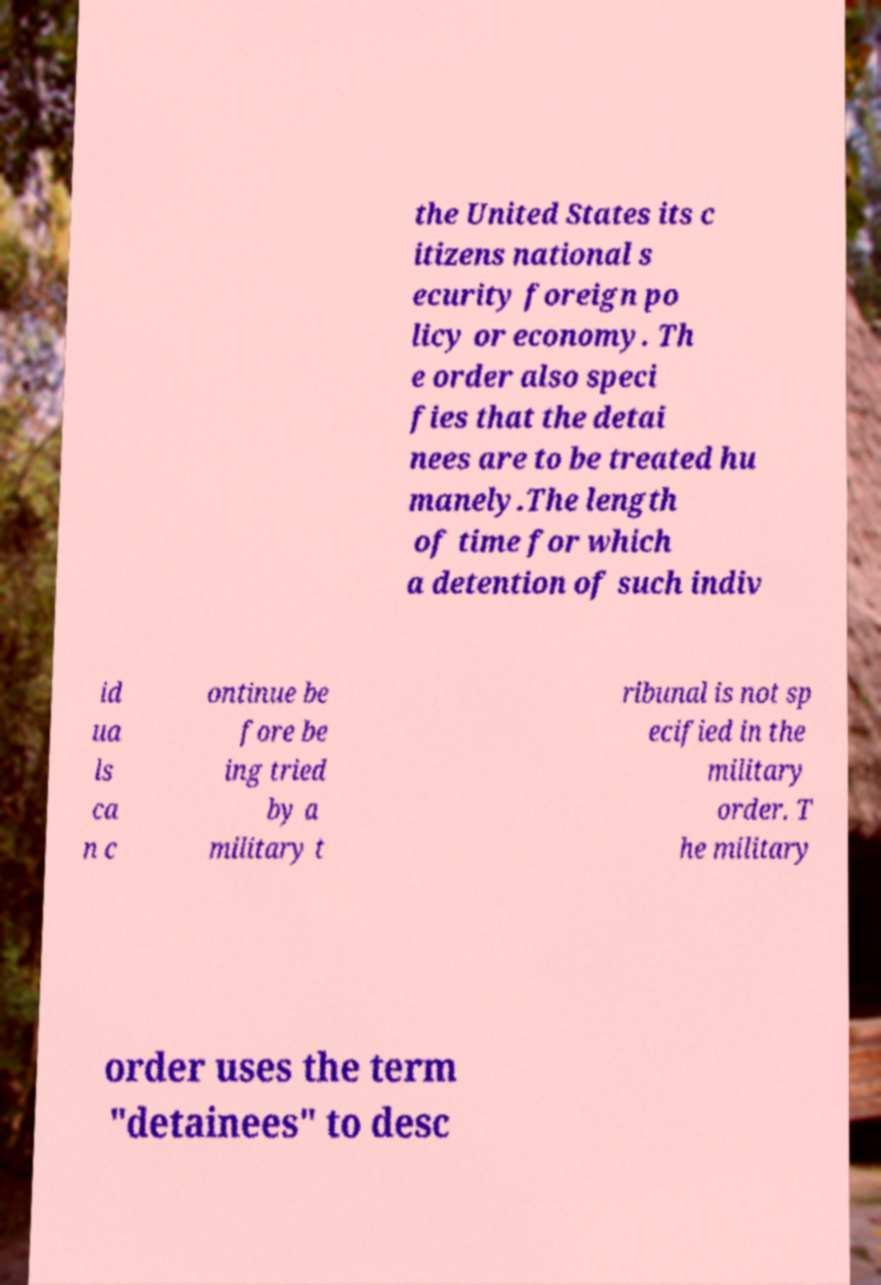There's text embedded in this image that I need extracted. Can you transcribe it verbatim? the United States its c itizens national s ecurity foreign po licy or economy. Th e order also speci fies that the detai nees are to be treated hu manely.The length of time for which a detention of such indiv id ua ls ca n c ontinue be fore be ing tried by a military t ribunal is not sp ecified in the military order. T he military order uses the term "detainees" to desc 